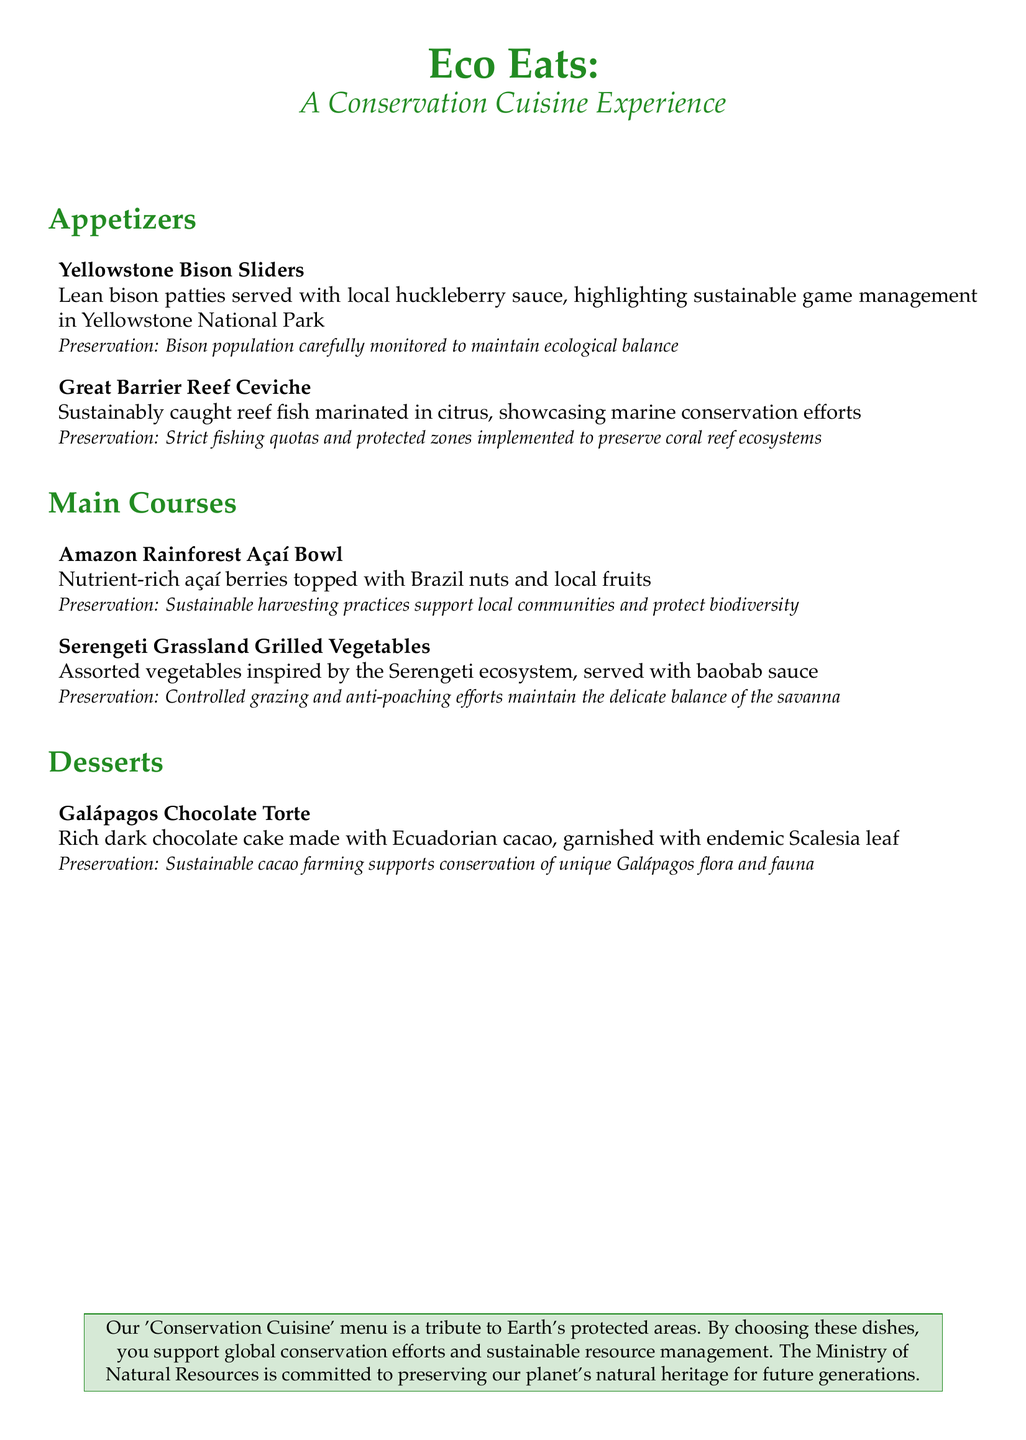What are the appetizers listed? The appetizers are specifically mentioned in the menu under the appetizers section.
Answer: Yellowtone Bison Sliders, Great Barrier Reef Ceviche What is the main ingredient in the Amazon Rainforest Açaí Bowl? The main ingredient for this dish is mentioned in the description under main courses.
Answer: Açaí berries What conservation method is highlighted in Yellowstone National Park? The document provides information regarding what preservation efforts are taken in Yellowstone National Park in the context of the dish.
Answer: Bison population carefully monitored How many main courses are listed on the menu? The menu lists different sections, and the number of main courses is calculated by counting those listed in that section.
Answer: 2 What special ingredient is used to garnish the Galápagos Chocolate Torte? The menu includes specific details on the dessert and its garnishing.
Answer: Endemic Scalesia leaf What ecological location inspired the Grilled Vegetables dish? The document states the inspiration behind the dish, providing a specific natural area.
Answer: Serengeti Grassland What type of fish is featured in the Great Barrier Reef Ceviche? The dish description mentions that the fish is sustainably caught.
Answer: Reef fish What is the purpose of the 'Conservation Cuisine' menu? The last section of the document summarizes the intent behind the menu and its contribution to conservation efforts.
Answer: Tribute to Earth's protected areas 